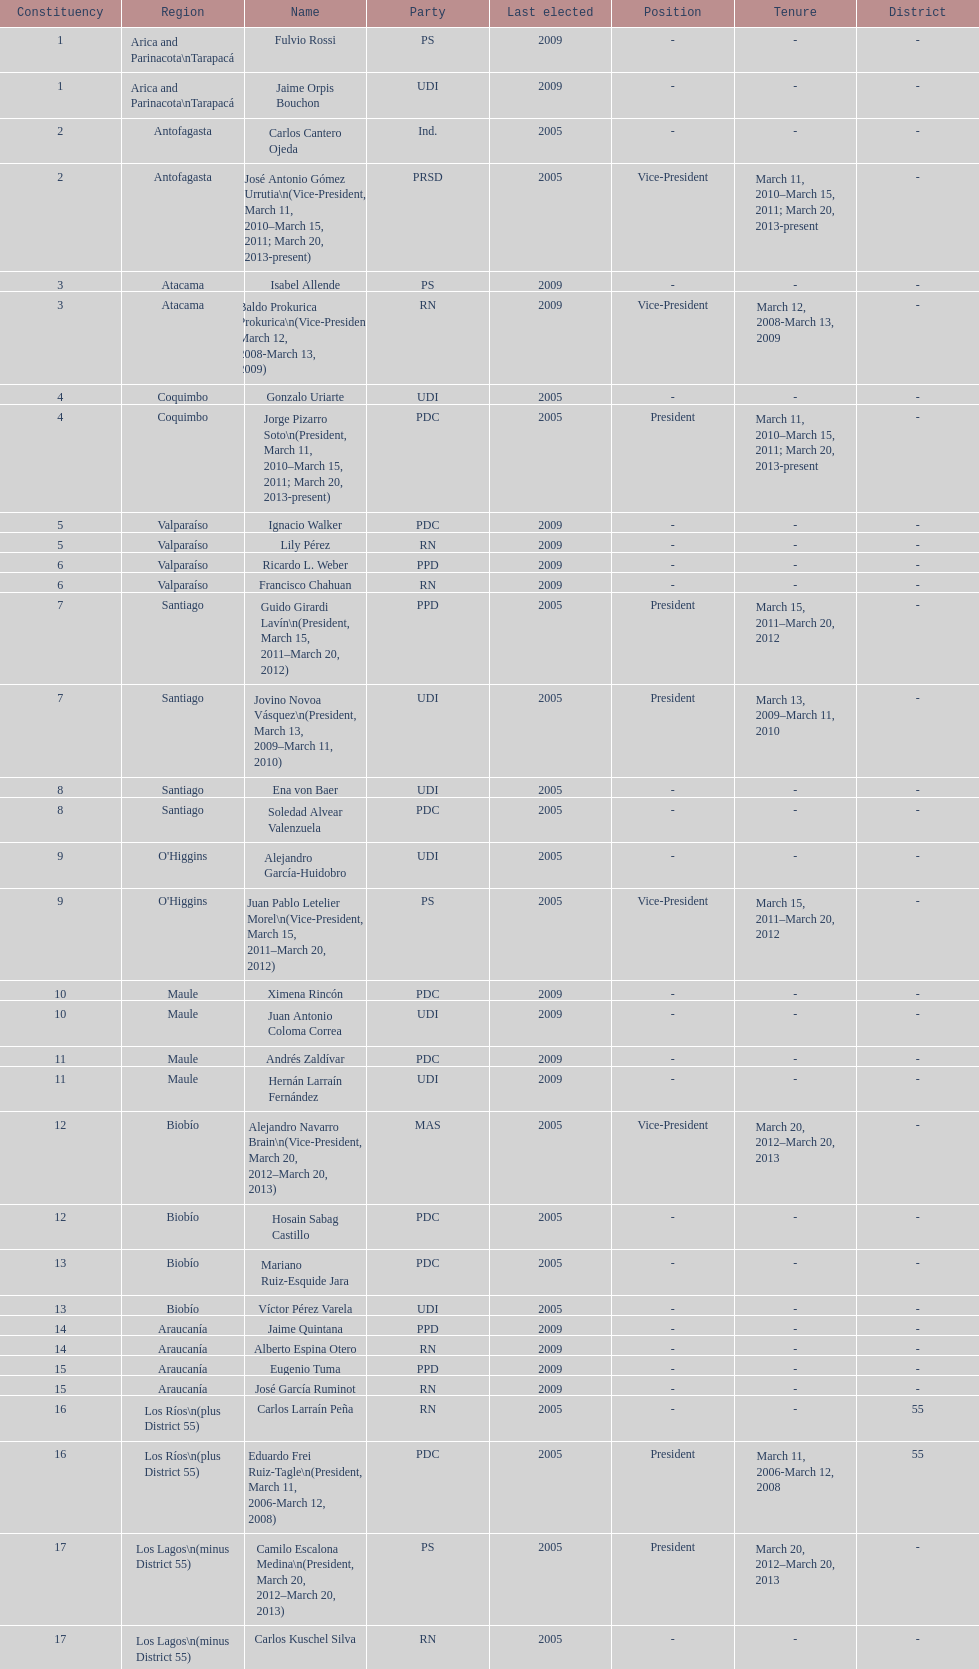Which region is listed below atacama? Coquimbo. 